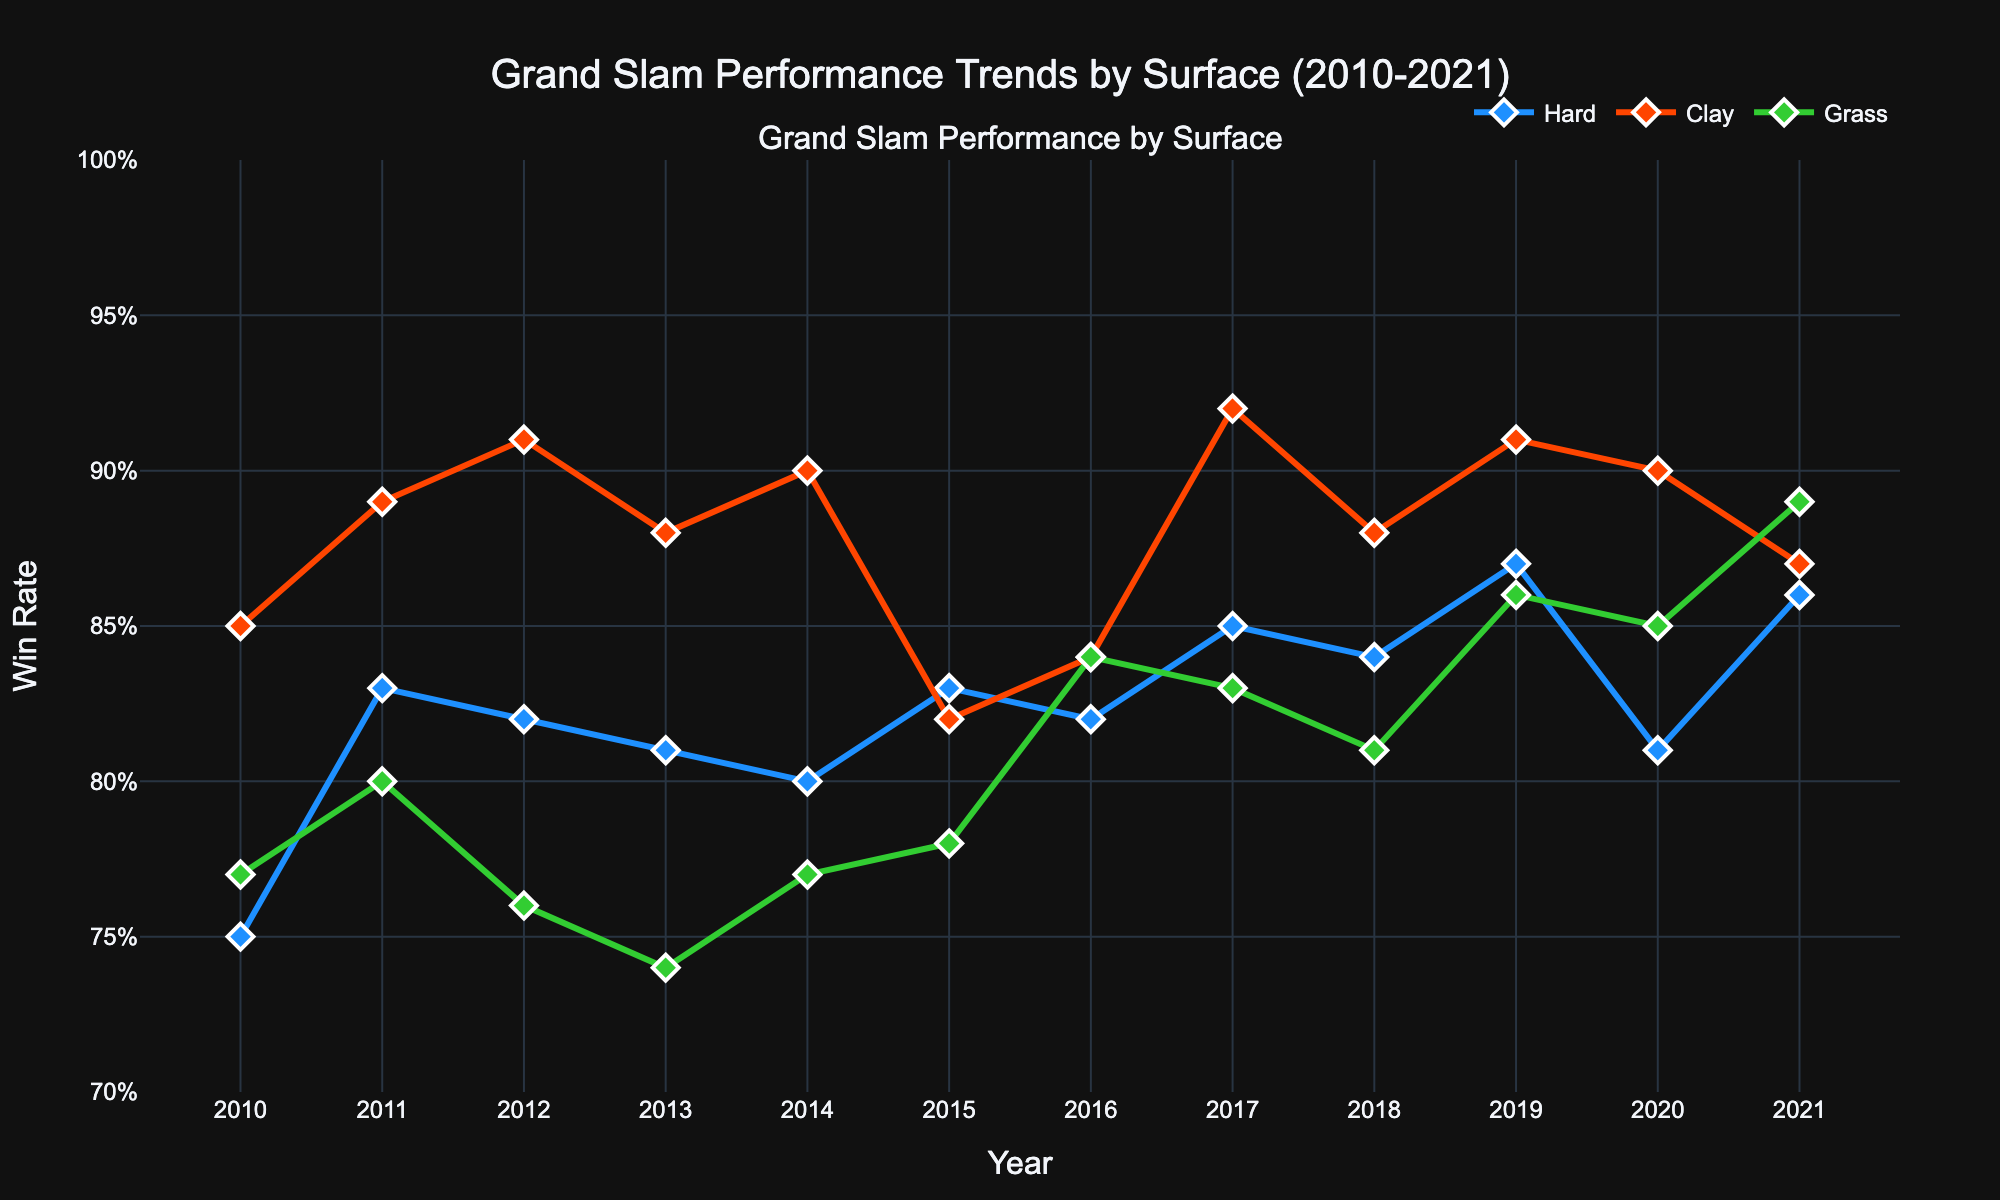What is the title of the plot? The title is located at the top of the figure and is clearly displayed.
Answer: Grand Slam Performance Trends by Surface (2010-2021) What is the win rate for Rafael Nadal on clay in 2021? By examining the figure, find the point corresponding to the clay surface and the year 2021. The win rate is displayed next to this point.
Answer: 0.87 Which surface shows the highest variability in win rates over the years? To determine this, compare the range and variability of the win rates for each surface type by visually assessing the spread of data points and the fluctuation of the trend lines for Hard, Clay, and Grass surfaces.
Answer: Grass In which year did Roger Federer achieve his highest win rate on grass? Look at the data points for Roger Federer on the grass surface across different years and find the peak value. The year associated with this peak is the answer.
Answer: 2017 Between 2015 and 2018, whose win rate increased the most on the hard surface? Identify the win rates on the hard surface for each player in 2015 and 2018, then calculate the difference for each player. The player with the largest increase is the answer.
Answer: Novak Djokovic How many Grand Slam surfaces are represented in the plot? Count the unique types of surfaces used in the Grand Slam tournaments as indicated by the distinct lines and legend entries.
Answer: 3 Which year had the highest overall win rate for Grand Slam tournaments? Compare the win rates across all surfaces for each year and identify the year where the highest win rate value appears.
Answer: 2017 What is the average win rate for Novak Djokovic on the hard surface from 2010 to 2021? Sum all the win rates of Novak Djokovic on the hard surface from each year, then divide by the number of years (11 in this case) to find the average.
Answer: 0.8286 Which surface shows the least variation in win rates over time? By examining the overall spread of the data points and the consistency of the trend lines, determine which surface has the least fluctuation in win rates.
Answer: Clay What's the difference in win rate between Rafael Nadal on clay and Novak Djokovic on hard in 2012? Locate the win rates for Rafael Nadal on clay and Novak Djokovic on hard for the year 2012, and subtract the win rate of Novak Djokovic from Rafael Nadal's win rate.
Answer: 0.09 